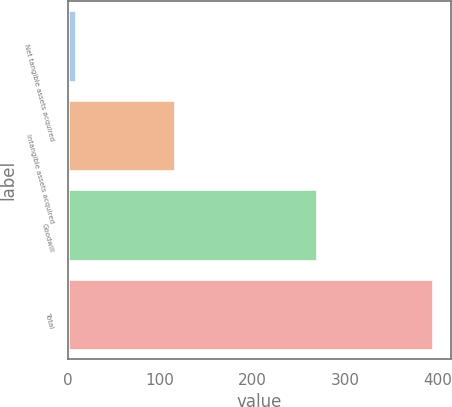Convert chart to OTSL. <chart><loc_0><loc_0><loc_500><loc_500><bar_chart><fcel>Net tangible assets acquired<fcel>Intangible assets acquired<fcel>Goodwill<fcel>Total<nl><fcel>8.8<fcel>116.5<fcel>269.2<fcel>394.5<nl></chart> 